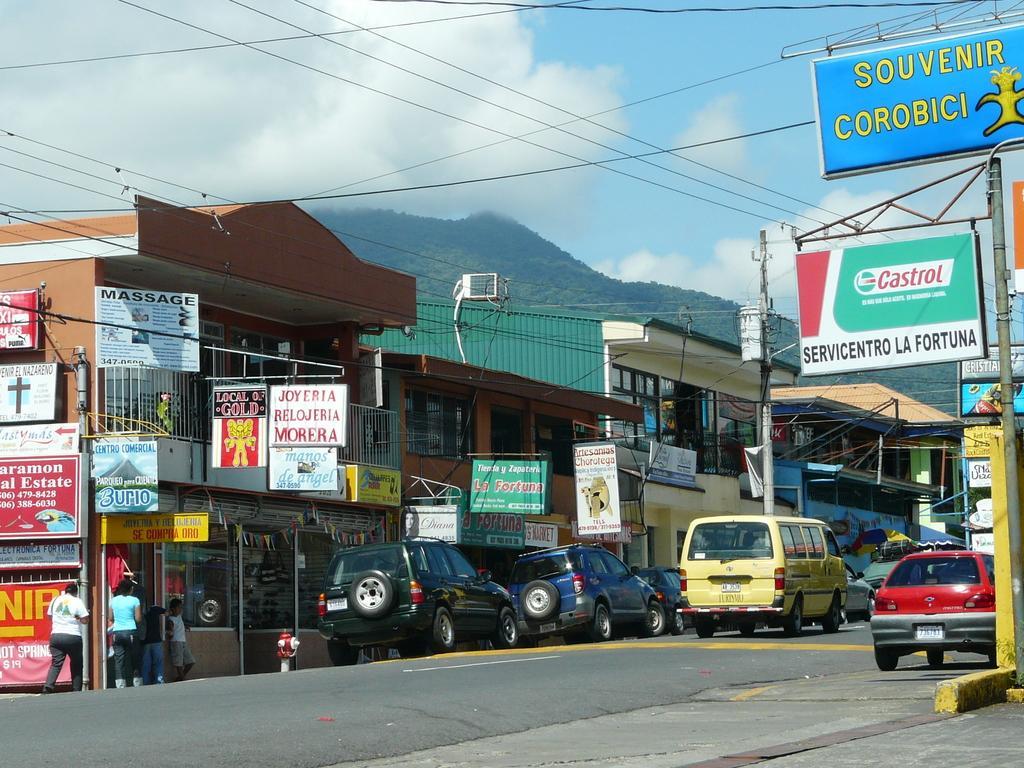In one or two sentences, can you explain what this image depicts? In the middle of the image there are some vehicles on the road and few people are walking. Behind the vehicles there are some buildings and poles, on the buildings there are some banners. Behind the buildings there is hill and clouds and sky. 